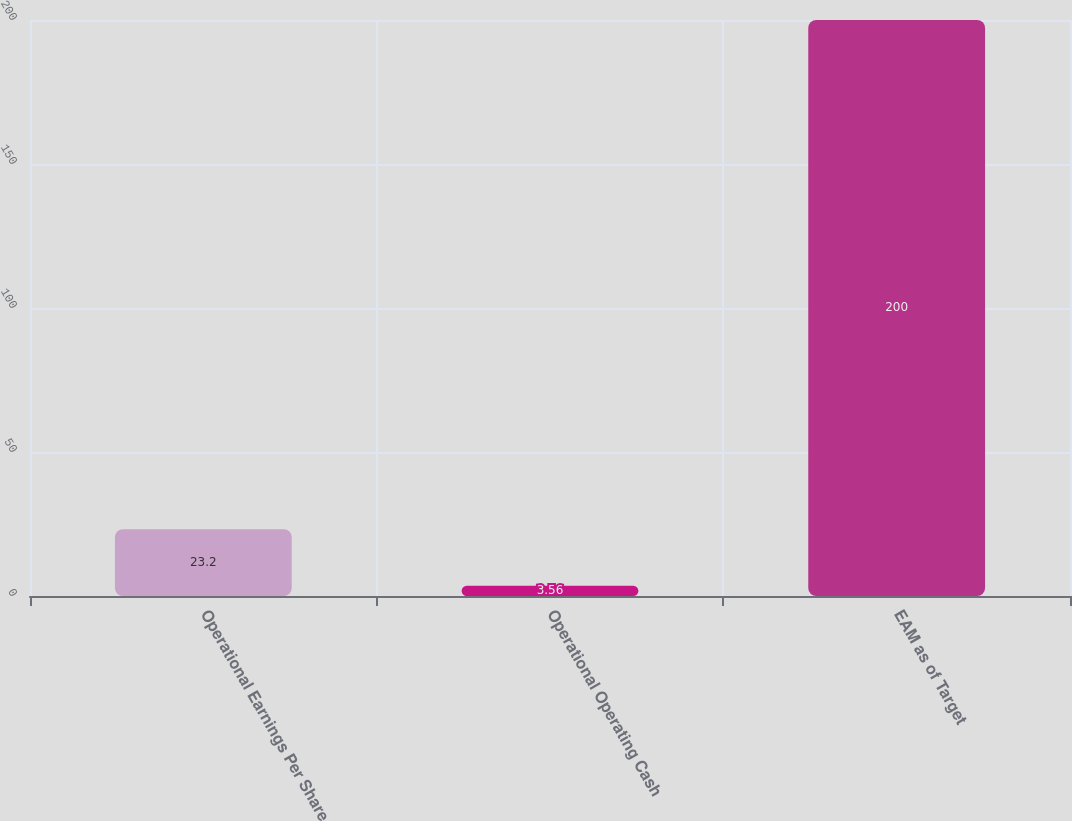<chart> <loc_0><loc_0><loc_500><loc_500><bar_chart><fcel>Operational Earnings Per Share<fcel>Operational Operating Cash<fcel>EAM as of Target<nl><fcel>23.2<fcel>3.56<fcel>200<nl></chart> 